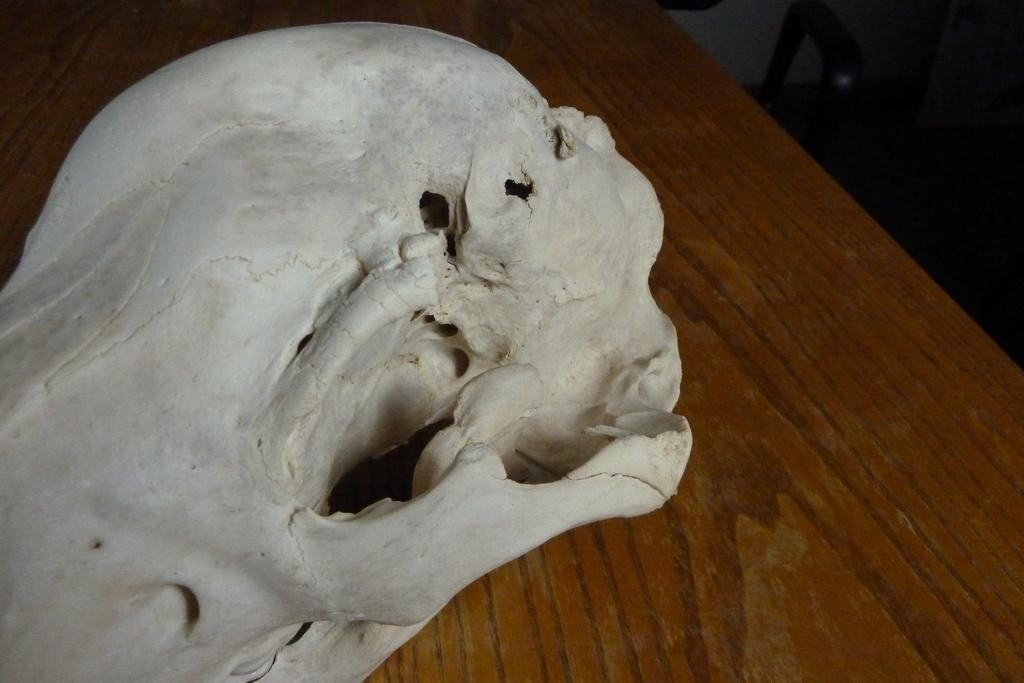What is the main subject of the image? There is a skull on a table in the image. What else can be seen in the image besides the skull? There are objects in the top right-hand corner of the image. Can you describe the location of these objects in the image? The objects in the top right-hand corner are in a dark area. What type of canvas is being used to paint the cherry in the image? There is no canvas or cherry present in the image; it features a skull on a table and objects in a dark area. 